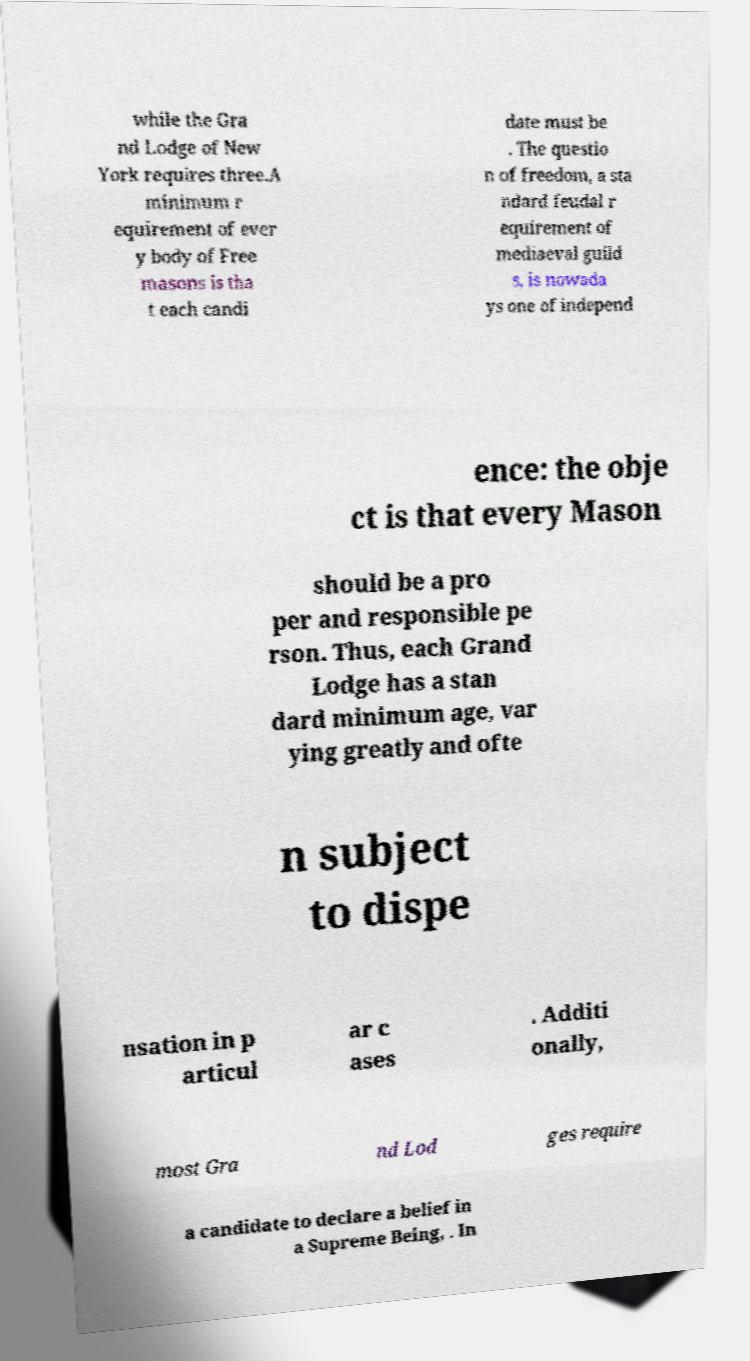Could you assist in decoding the text presented in this image and type it out clearly? while the Gra nd Lodge of New York requires three.A minimum r equirement of ever y body of Free masons is tha t each candi date must be . The questio n of freedom, a sta ndard feudal r equirement of mediaeval guild s, is nowada ys one of independ ence: the obje ct is that every Mason should be a pro per and responsible pe rson. Thus, each Grand Lodge has a stan dard minimum age, var ying greatly and ofte n subject to dispe nsation in p articul ar c ases . Additi onally, most Gra nd Lod ges require a candidate to declare a belief in a Supreme Being, . In 